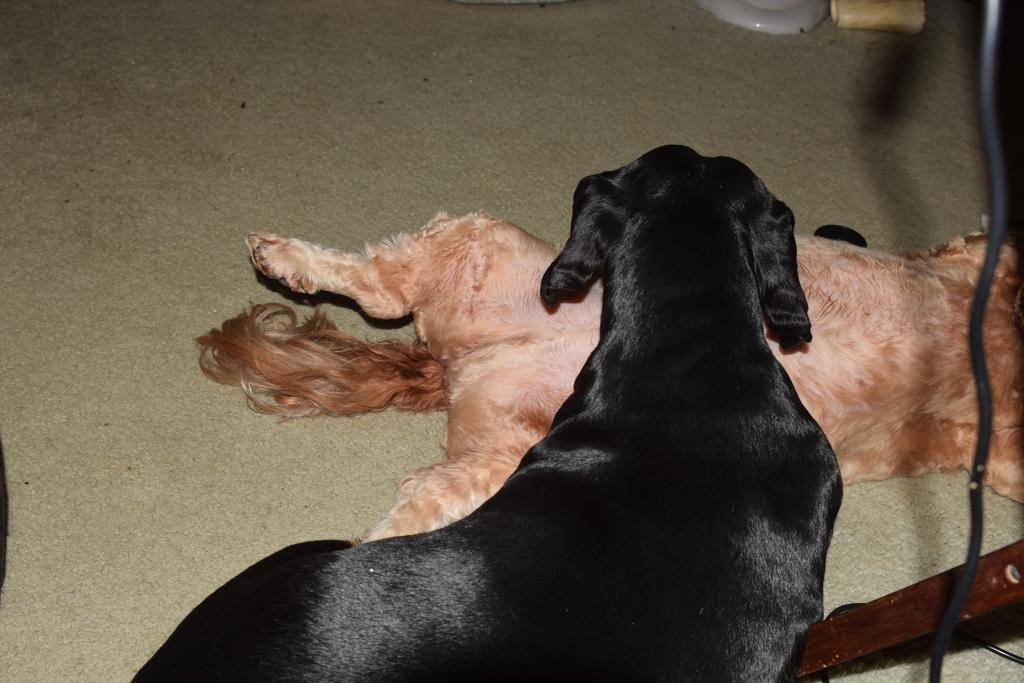What type of animals are present in the image? There are dogs in the image. What position are the dogs in? The dogs are laying on the floor. What books are the dogs reading in the image? There are no books present in the image; it features dogs laying on the floor. What song is being sung by the dogs in the image? There is no song being sung by the dogs in the image; they are simply laying on the floor. 